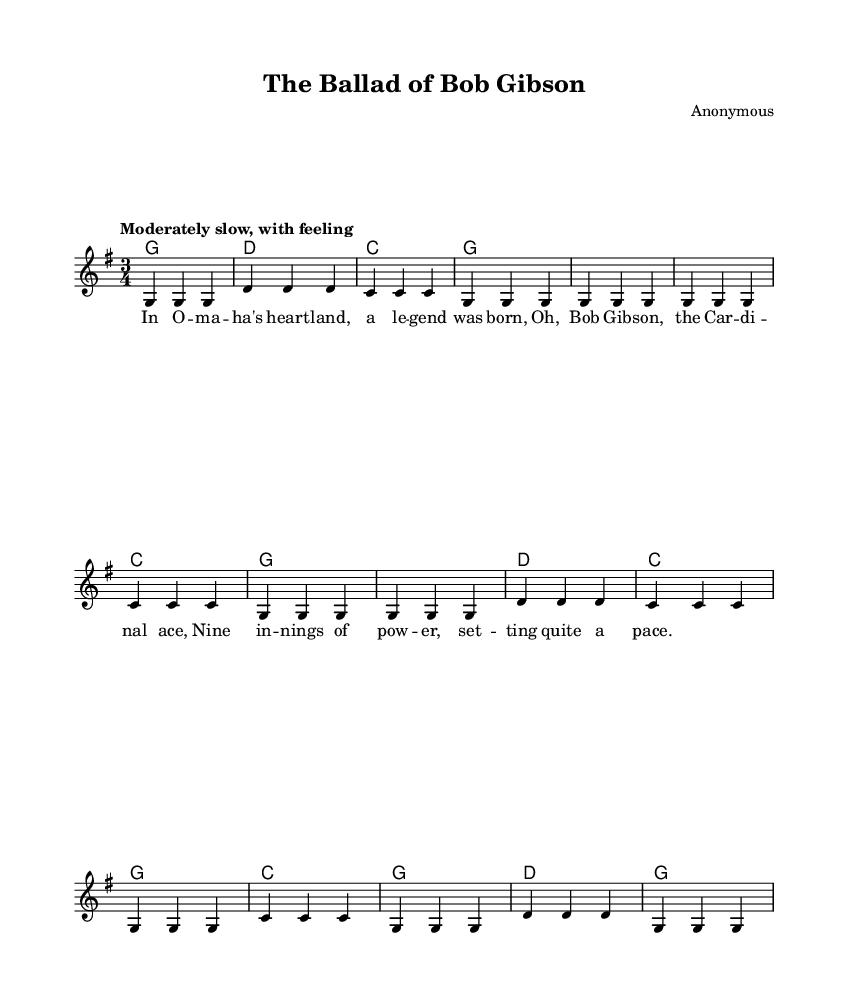What is the key signature of this music? The key signature indicates G major, which has one sharp (F#). This can be identified by observing the key signature on the music staff.
Answer: G major What is the time signature of this music? The time signature is 3/4, meaning there are three beats in each measure and the quarter note gets one beat. This is visible at the beginning of the sheet music.
Answer: 3/4 What is the tempo marking for this piece? The tempo marking states "Moderately slow, with feeling," which provides a specific instruction for how the music should be performed. This is noted at the beginning under the global settings.
Answer: Moderately slow, with feeling How many measures are in the chorus section? The chorus section consists of 8 measures. By counting the measures indicated in the chorus part of the melody, we can determine the total.
Answer: 8 What do the lyrics suggest about Bob Gibson? The lyrics reference Bob Gibson as a "legend" and highlight his prowess as the "Cardinal ace," emphasizing his notable performance in baseball. This can be deduced from the text of the lyrics provided.
Answer: Legend, Cardinal ace What structure is used in the song? The song uses a traditional verse-chorus structure, which can be recognized by sequentially labeled sections within the sheet music where the verse and chorus are different.
Answer: Verse-chorus What type of music does this piece represent? This piece represents folk music, as indicated by its storytelling nature, references to legendary figures, and simple melodic structure typical of folk ballads. This can be inferred from the style and content of the lyrics and melody.
Answer: Folk 